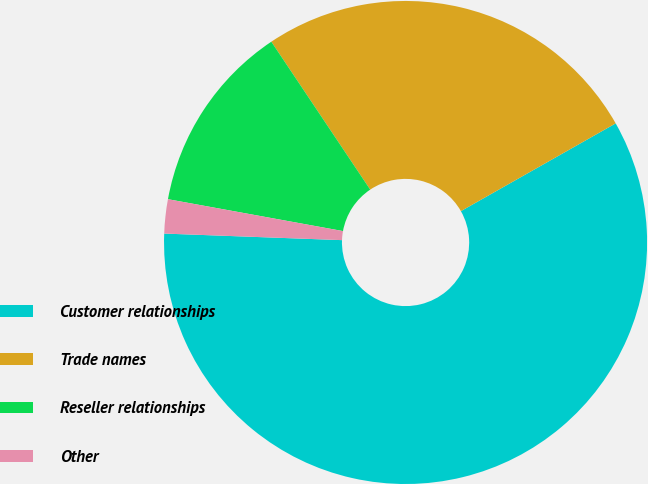Convert chart. <chart><loc_0><loc_0><loc_500><loc_500><pie_chart><fcel>Customer relationships<fcel>Trade names<fcel>Reseller relationships<fcel>Other<nl><fcel>58.79%<fcel>26.17%<fcel>12.75%<fcel>2.28%<nl></chart> 